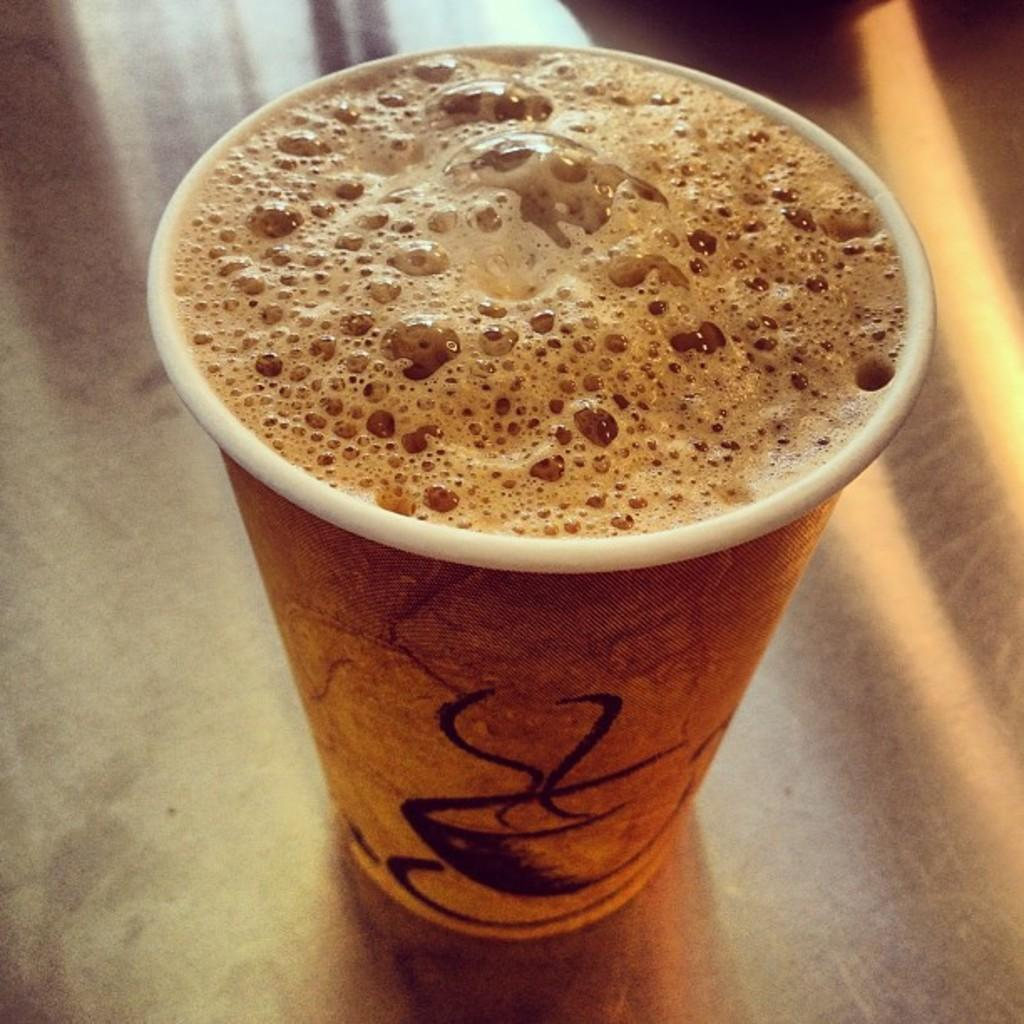What is in the cup that is visible in the image? The cup contains a brown color liquid. Where is the cup located in the image? The cup is on a table. What type of knot can be seen on the table in the image? There is no knot present on the table in the image. 